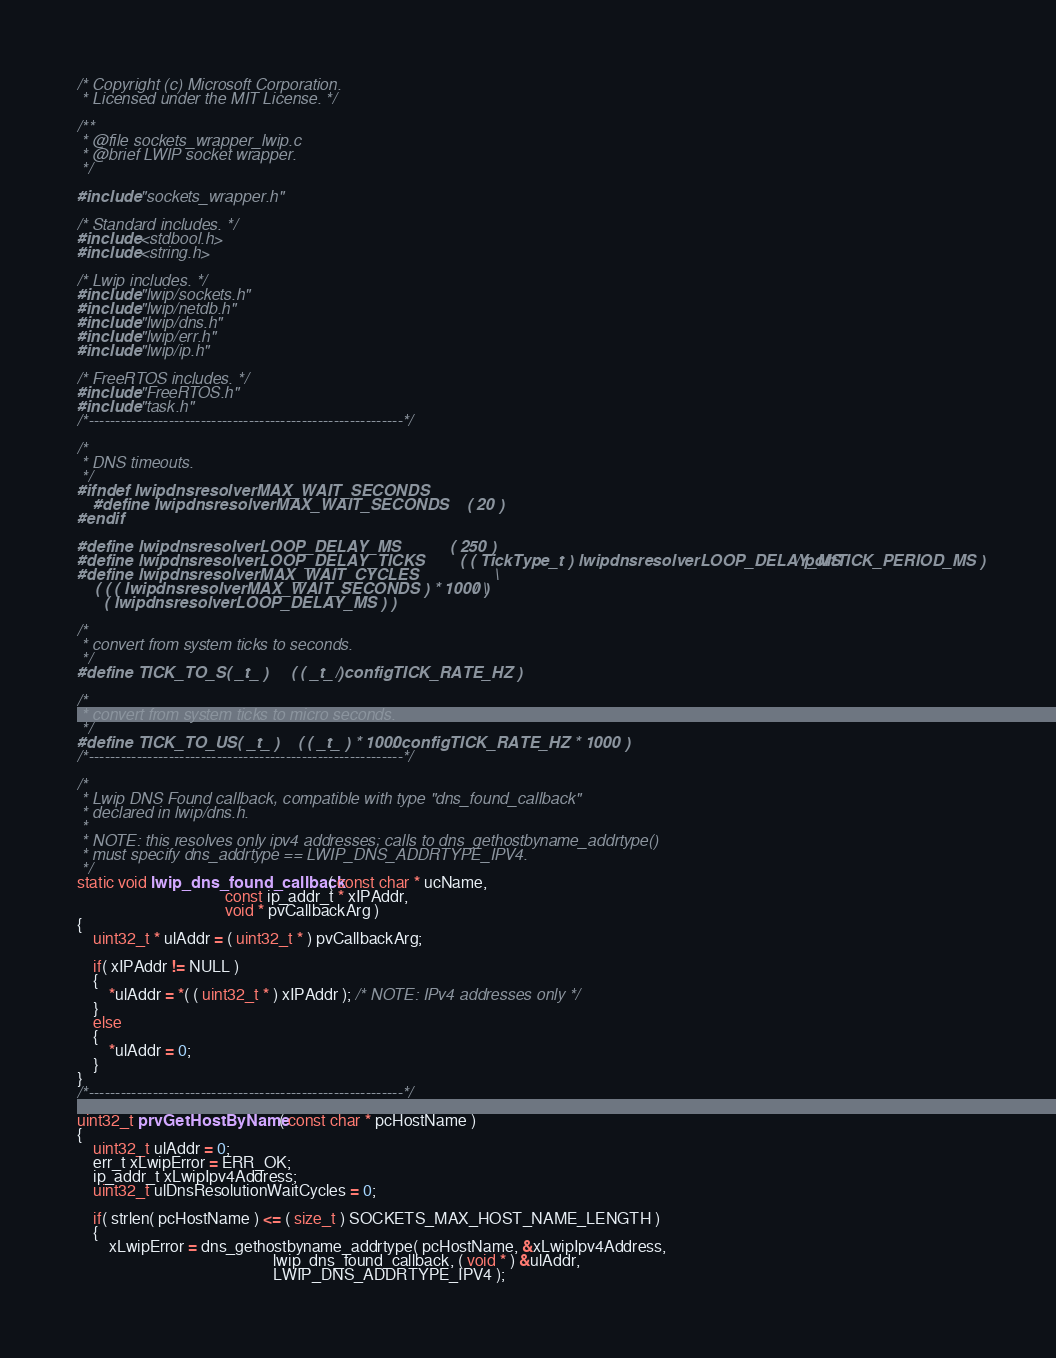Convert code to text. <code><loc_0><loc_0><loc_500><loc_500><_C_>/* Copyright (c) Microsoft Corporation.
 * Licensed under the MIT License. */

/**
 * @file sockets_wrapper_lwip.c
 * @brief LWIP socket wrapper.
 */

#include "sockets_wrapper.h"

/* Standard includes. */
#include <stdbool.h>
#include <string.h>

/* Lwip includes. */
#include "lwip/sockets.h"
#include "lwip/netdb.h"
#include "lwip/dns.h"
#include "lwip/err.h"
#include "lwip/ip.h"

/* FreeRTOS includes. */
#include "FreeRTOS.h"
#include "task.h"
/*-----------------------------------------------------------*/

/*
 * DNS timeouts.
 */
#ifndef lwipdnsresolverMAX_WAIT_SECONDS
    #define lwipdnsresolverMAX_WAIT_SECONDS    ( 20 )
#endif

#define lwipdnsresolverLOOP_DELAY_MS           ( 250 )
#define lwipdnsresolverLOOP_DELAY_TICKS        ( ( TickType_t ) lwipdnsresolverLOOP_DELAY_MS / portTICK_PERIOD_MS )
#define lwipdnsresolverMAX_WAIT_CYCLES                 \
    ( ( ( lwipdnsresolverMAX_WAIT_SECONDS ) * 1000 ) / \
      ( lwipdnsresolverLOOP_DELAY_MS ) )

/*
 * convert from system ticks to seconds.
 */
#define TICK_TO_S( _t_ )     ( ( _t_ ) / configTICK_RATE_HZ )

/*
 * convert from system ticks to micro seconds.
 */
#define TICK_TO_US( _t_ )    ( ( _t_ ) * 1000 / configTICK_RATE_HZ * 1000 )
/*-----------------------------------------------------------*/

/*
 * Lwip DNS Found callback, compatible with type "dns_found_callback"
 * declared in lwip/dns.h.
 *
 * NOTE: this resolves only ipv4 addresses; calls to dns_gethostbyname_addrtype()
 * must specify dns_addrtype == LWIP_DNS_ADDRTYPE_IPV4.
 */
static void lwip_dns_found_callback( const char * ucName,
                                     const ip_addr_t * xIPAddr,
                                     void * pvCallbackArg )
{
    uint32_t * ulAddr = ( uint32_t * ) pvCallbackArg;

    if( xIPAddr != NULL )
    {
        *ulAddr = *( ( uint32_t * ) xIPAddr ); /* NOTE: IPv4 addresses only */
    }
    else
    {
        *ulAddr = 0;
    }
}
/*-----------------------------------------------------------*/

uint32_t prvGetHostByName( const char * pcHostName )
{
    uint32_t ulAddr = 0;
    err_t xLwipError = ERR_OK;
    ip_addr_t xLwipIpv4Address;
    uint32_t ulDnsResolutionWaitCycles = 0;

    if( strlen( pcHostName ) <= ( size_t ) SOCKETS_MAX_HOST_NAME_LENGTH )
    {
        xLwipError = dns_gethostbyname_addrtype( pcHostName, &xLwipIpv4Address,
                                                 lwip_dns_found_callback, ( void * ) &ulAddr,
                                                 LWIP_DNS_ADDRTYPE_IPV4 );
</code> 